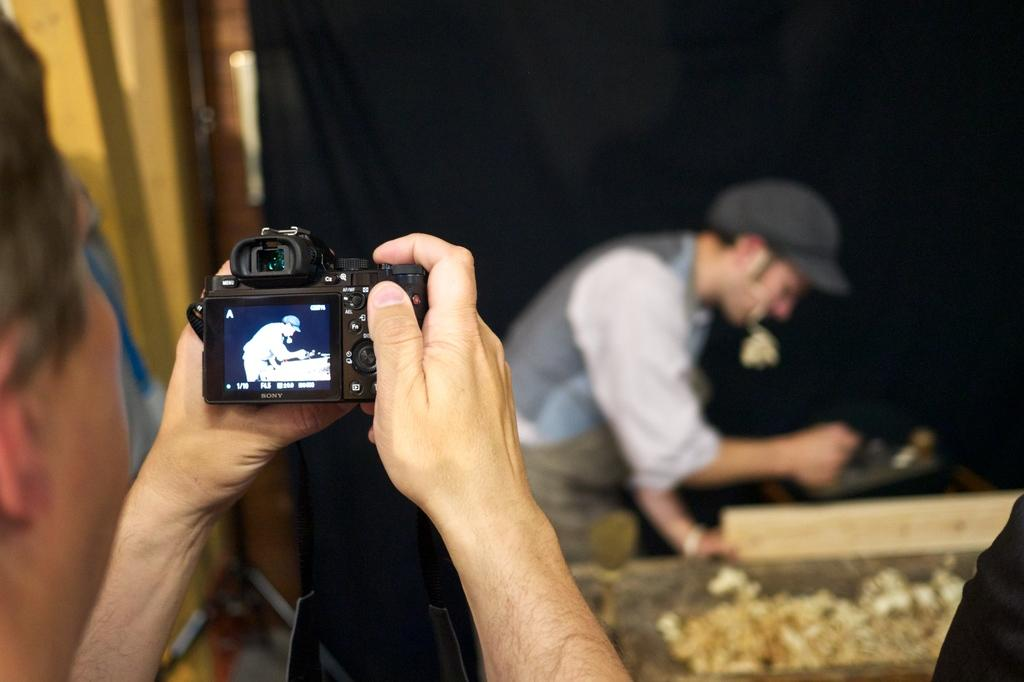How many people are in the image? There are two persons in the image. What is one of the persons wearing? One of the persons is wearing a cap. What is the person wearing a cap doing in the image? The person wearing a cap is taking a snap with a camera. How does the person in the image twist the camera while taking a snap? The person in the image is not twisting the camera while taking a snap; they are simply holding it to take a photo. 